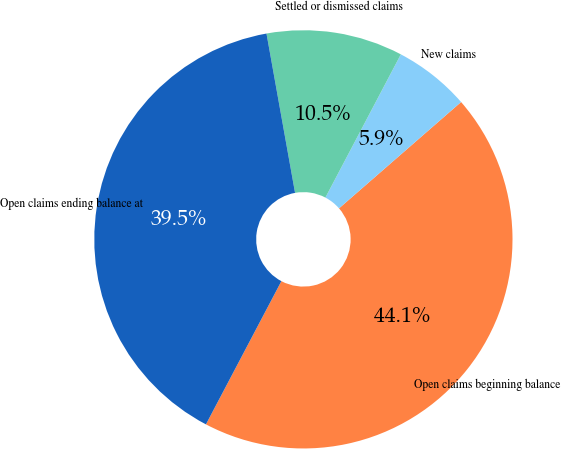Convert chart. <chart><loc_0><loc_0><loc_500><loc_500><pie_chart><fcel>Open claims beginning balance<fcel>New claims<fcel>Settled or dismissed claims<fcel>Open claims ending balance at<nl><fcel>44.12%<fcel>5.88%<fcel>10.54%<fcel>39.46%<nl></chart> 